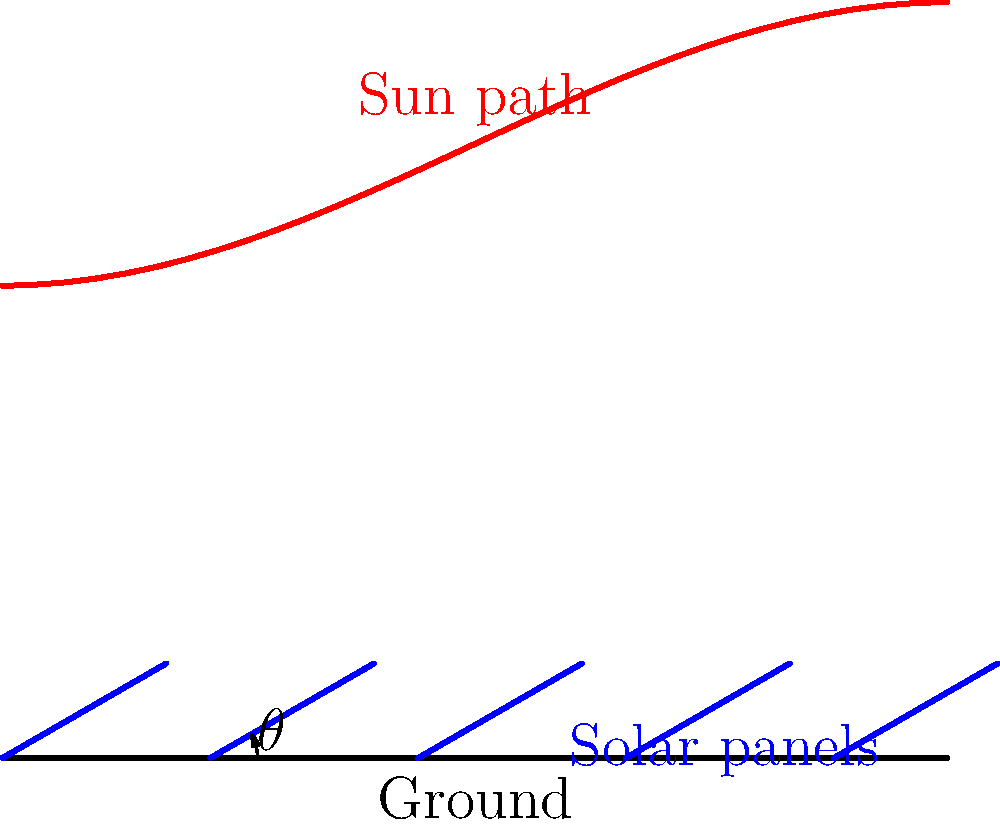In designing an efficient solar panel array layout, you need to determine the optimal tilt angle $\theta$ for fixed panels to maximize annual energy capture. Given that the sun's path varies throughout the year as shown in the diagram, and considering factors such as latitude, seasonal variations, and potential shading, what approach would you use to calculate the ideal tilt angle $\theta$ for this location? To determine the optimal tilt angle $\theta$ for fixed solar panels, we need to consider several factors:

1. Latitude: The general rule of thumb is to set the tilt angle equal to the latitude of the location. This provides a good starting point.

2. Seasonal variations: The sun's path changes throughout the year. In summer, it's higher in the sky, while in winter, it's lower.

3. Energy demand: Consider whether energy demand is higher in summer or winter, which might influence the optimal angle.

4. Calculation method:
   a) Use the average solar elevation angle: $\theta_{optimal} = 90^\circ - \phi + \delta$
      Where $\phi$ is the latitude and $\delta$ is the average declination angle (approximately 23.45°).
   
   b) Alternatively, use a more complex formula: $\theta_{optimal} = 3.7 + 0.69|\phi|$
      This empirical formula takes into account the non-linear relationship between latitude and optimal tilt.

5. Shading analysis: Perform a shading analysis to ensure panels don't shade each other at the calculated angle.

6. Fine-tuning: Use solar insolation data for the specific location to fine-tune the angle.

7. Verification: Use software simulations (e.g., PVsyst) to verify and optimize the calculated angle.

The final step would be to compare the energy output at various tilt angles using simulation software and choose the angle that provides the maximum annual energy yield.
Answer: Calculate initial angle using $\theta_{optimal} = 3.7 + 0.69|\phi|$, then fine-tune with local solar data and simulations. 